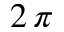Convert formula to latex. <formula><loc_0><loc_0><loc_500><loc_500>2 \, \pi</formula> 